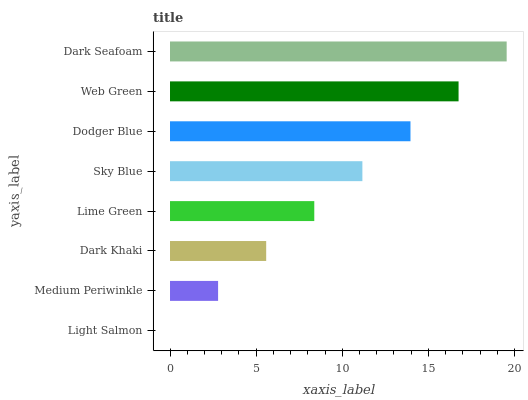Is Light Salmon the minimum?
Answer yes or no. Yes. Is Dark Seafoam the maximum?
Answer yes or no. Yes. Is Medium Periwinkle the minimum?
Answer yes or no. No. Is Medium Periwinkle the maximum?
Answer yes or no. No. Is Medium Periwinkle greater than Light Salmon?
Answer yes or no. Yes. Is Light Salmon less than Medium Periwinkle?
Answer yes or no. Yes. Is Light Salmon greater than Medium Periwinkle?
Answer yes or no. No. Is Medium Periwinkle less than Light Salmon?
Answer yes or no. No. Is Sky Blue the high median?
Answer yes or no. Yes. Is Lime Green the low median?
Answer yes or no. Yes. Is Dodger Blue the high median?
Answer yes or no. No. Is Dodger Blue the low median?
Answer yes or no. No. 